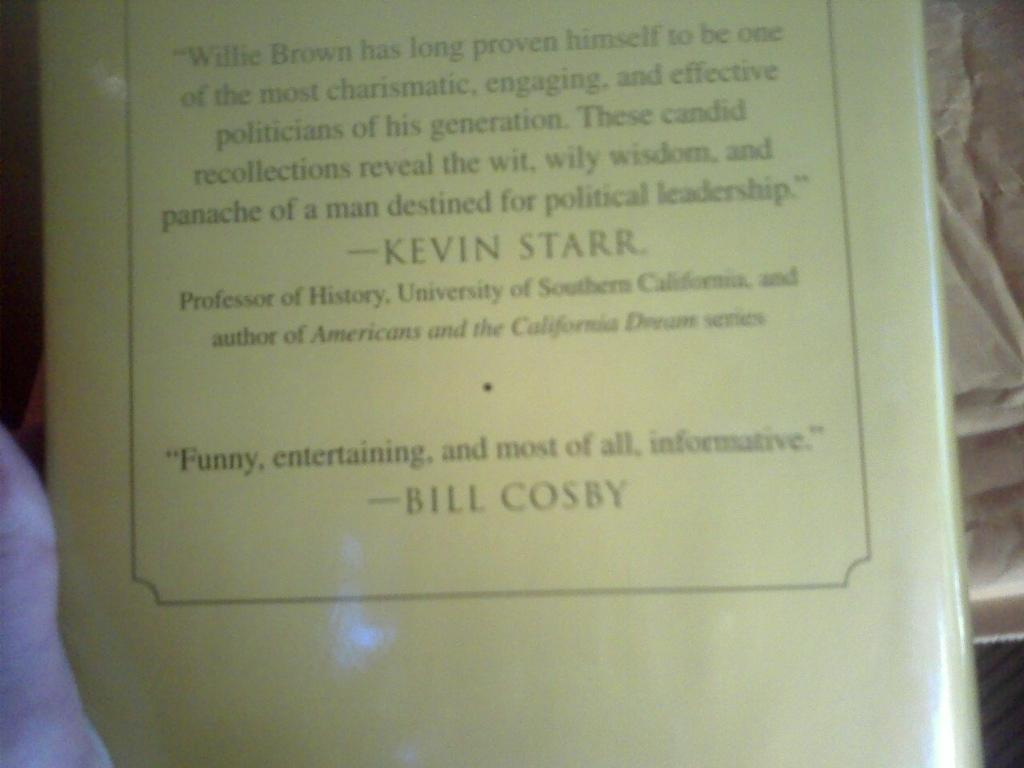<image>
Give a short and clear explanation of the subsequent image. A book that is on a page with reviews by Bill Cosby and Kevin Starr 